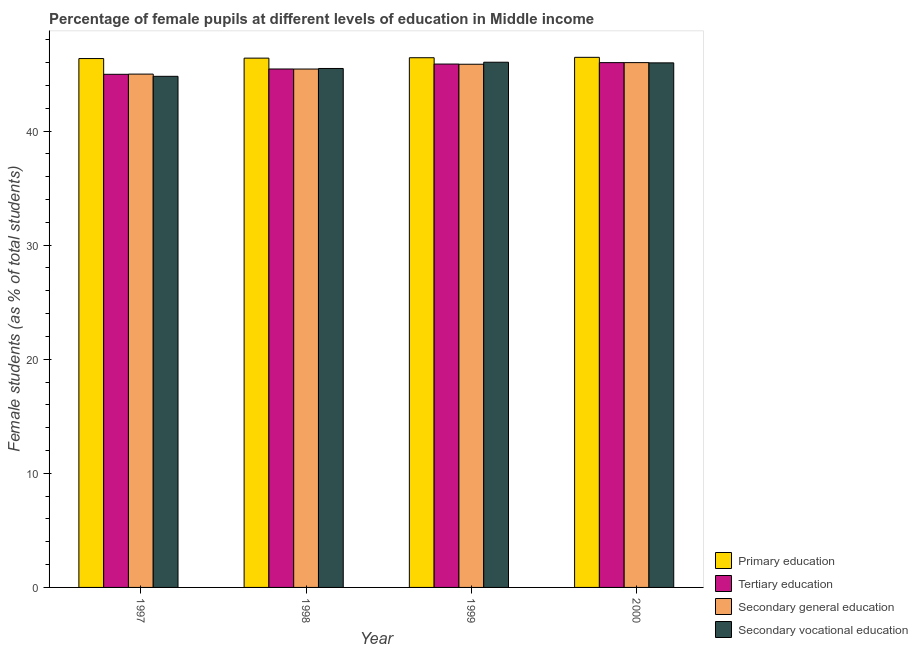Are the number of bars per tick equal to the number of legend labels?
Make the answer very short. Yes. How many bars are there on the 3rd tick from the right?
Offer a terse response. 4. What is the label of the 2nd group of bars from the left?
Give a very brief answer. 1998. In how many cases, is the number of bars for a given year not equal to the number of legend labels?
Keep it short and to the point. 0. What is the percentage of female students in secondary education in 1998?
Make the answer very short. 45.44. Across all years, what is the maximum percentage of female students in secondary education?
Provide a succinct answer. 46. Across all years, what is the minimum percentage of female students in primary education?
Offer a very short reply. 46.36. In which year was the percentage of female students in secondary vocational education maximum?
Give a very brief answer. 1999. In which year was the percentage of female students in secondary vocational education minimum?
Your response must be concise. 1997. What is the total percentage of female students in primary education in the graph?
Your answer should be compact. 185.65. What is the difference between the percentage of female students in primary education in 1998 and that in 1999?
Your answer should be compact. -0.04. What is the difference between the percentage of female students in secondary vocational education in 1998 and the percentage of female students in primary education in 2000?
Offer a terse response. -0.49. What is the average percentage of female students in secondary education per year?
Your answer should be compact. 45.57. What is the ratio of the percentage of female students in primary education in 1999 to that in 2000?
Provide a succinct answer. 1. Is the difference between the percentage of female students in secondary education in 1997 and 1998 greater than the difference between the percentage of female students in primary education in 1997 and 1998?
Make the answer very short. No. What is the difference between the highest and the second highest percentage of female students in secondary vocational education?
Offer a very short reply. 0.06. What is the difference between the highest and the lowest percentage of female students in tertiary education?
Give a very brief answer. 1.02. Is it the case that in every year, the sum of the percentage of female students in secondary vocational education and percentage of female students in secondary education is greater than the sum of percentage of female students in primary education and percentage of female students in tertiary education?
Provide a short and direct response. No. What does the 1st bar from the left in 2000 represents?
Give a very brief answer. Primary education. What does the 3rd bar from the right in 2000 represents?
Your answer should be very brief. Tertiary education. Is it the case that in every year, the sum of the percentage of female students in primary education and percentage of female students in tertiary education is greater than the percentage of female students in secondary education?
Your answer should be compact. Yes. How many bars are there?
Make the answer very short. 16. What is the difference between two consecutive major ticks on the Y-axis?
Provide a succinct answer. 10. Are the values on the major ticks of Y-axis written in scientific E-notation?
Ensure brevity in your answer.  No. Does the graph contain any zero values?
Keep it short and to the point. No. Does the graph contain grids?
Provide a short and direct response. No. How many legend labels are there?
Offer a very short reply. 4. How are the legend labels stacked?
Give a very brief answer. Vertical. What is the title of the graph?
Your response must be concise. Percentage of female pupils at different levels of education in Middle income. Does "Greece" appear as one of the legend labels in the graph?
Ensure brevity in your answer.  No. What is the label or title of the X-axis?
Your answer should be very brief. Year. What is the label or title of the Y-axis?
Offer a very short reply. Female students (as % of total students). What is the Female students (as % of total students) in Primary education in 1997?
Ensure brevity in your answer.  46.36. What is the Female students (as % of total students) in Tertiary education in 1997?
Make the answer very short. 44.98. What is the Female students (as % of total students) of Secondary general education in 1997?
Give a very brief answer. 44.99. What is the Female students (as % of total students) of Secondary vocational education in 1997?
Provide a succinct answer. 44.8. What is the Female students (as % of total students) of Primary education in 1998?
Provide a short and direct response. 46.39. What is the Female students (as % of total students) in Tertiary education in 1998?
Provide a short and direct response. 45.44. What is the Female students (as % of total students) of Secondary general education in 1998?
Offer a very short reply. 45.44. What is the Female students (as % of total students) of Secondary vocational education in 1998?
Your answer should be very brief. 45.49. What is the Female students (as % of total students) in Primary education in 1999?
Ensure brevity in your answer.  46.43. What is the Female students (as % of total students) of Tertiary education in 1999?
Provide a succinct answer. 45.88. What is the Female students (as % of total students) in Secondary general education in 1999?
Your response must be concise. 45.86. What is the Female students (as % of total students) in Secondary vocational education in 1999?
Make the answer very short. 46.04. What is the Female students (as % of total students) in Primary education in 2000?
Your answer should be compact. 46.46. What is the Female students (as % of total students) in Tertiary education in 2000?
Keep it short and to the point. 46. What is the Female students (as % of total students) of Secondary general education in 2000?
Give a very brief answer. 46. What is the Female students (as % of total students) of Secondary vocational education in 2000?
Offer a terse response. 45.98. Across all years, what is the maximum Female students (as % of total students) in Primary education?
Keep it short and to the point. 46.46. Across all years, what is the maximum Female students (as % of total students) in Tertiary education?
Make the answer very short. 46. Across all years, what is the maximum Female students (as % of total students) of Secondary general education?
Provide a short and direct response. 46. Across all years, what is the maximum Female students (as % of total students) of Secondary vocational education?
Make the answer very short. 46.04. Across all years, what is the minimum Female students (as % of total students) of Primary education?
Ensure brevity in your answer.  46.36. Across all years, what is the minimum Female students (as % of total students) in Tertiary education?
Give a very brief answer. 44.98. Across all years, what is the minimum Female students (as % of total students) of Secondary general education?
Make the answer very short. 44.99. Across all years, what is the minimum Female students (as % of total students) in Secondary vocational education?
Provide a short and direct response. 44.8. What is the total Female students (as % of total students) of Primary education in the graph?
Your answer should be compact. 185.65. What is the total Female students (as % of total students) in Tertiary education in the graph?
Ensure brevity in your answer.  182.29. What is the total Female students (as % of total students) of Secondary general education in the graph?
Provide a succinct answer. 182.29. What is the total Female students (as % of total students) in Secondary vocational education in the graph?
Your answer should be very brief. 182.3. What is the difference between the Female students (as % of total students) in Primary education in 1997 and that in 1998?
Your answer should be compact. -0.04. What is the difference between the Female students (as % of total students) in Tertiary education in 1997 and that in 1998?
Your answer should be very brief. -0.47. What is the difference between the Female students (as % of total students) in Secondary general education in 1997 and that in 1998?
Give a very brief answer. -0.44. What is the difference between the Female students (as % of total students) of Secondary vocational education in 1997 and that in 1998?
Provide a short and direct response. -0.69. What is the difference between the Female students (as % of total students) of Primary education in 1997 and that in 1999?
Keep it short and to the point. -0.07. What is the difference between the Female students (as % of total students) in Tertiary education in 1997 and that in 1999?
Make the answer very short. -0.9. What is the difference between the Female students (as % of total students) in Secondary general education in 1997 and that in 1999?
Give a very brief answer. -0.87. What is the difference between the Female students (as % of total students) of Secondary vocational education in 1997 and that in 1999?
Make the answer very short. -1.24. What is the difference between the Female students (as % of total students) of Primary education in 1997 and that in 2000?
Ensure brevity in your answer.  -0.11. What is the difference between the Female students (as % of total students) of Tertiary education in 1997 and that in 2000?
Provide a succinct answer. -1.02. What is the difference between the Female students (as % of total students) of Secondary general education in 1997 and that in 2000?
Offer a terse response. -1.01. What is the difference between the Female students (as % of total students) of Secondary vocational education in 1997 and that in 2000?
Give a very brief answer. -1.18. What is the difference between the Female students (as % of total students) in Primary education in 1998 and that in 1999?
Provide a short and direct response. -0.04. What is the difference between the Female students (as % of total students) of Tertiary education in 1998 and that in 1999?
Your response must be concise. -0.43. What is the difference between the Female students (as % of total students) of Secondary general education in 1998 and that in 1999?
Keep it short and to the point. -0.42. What is the difference between the Female students (as % of total students) of Secondary vocational education in 1998 and that in 1999?
Your answer should be very brief. -0.55. What is the difference between the Female students (as % of total students) in Primary education in 1998 and that in 2000?
Your answer should be very brief. -0.07. What is the difference between the Female students (as % of total students) in Tertiary education in 1998 and that in 2000?
Give a very brief answer. -0.56. What is the difference between the Female students (as % of total students) of Secondary general education in 1998 and that in 2000?
Give a very brief answer. -0.56. What is the difference between the Female students (as % of total students) of Secondary vocational education in 1998 and that in 2000?
Provide a short and direct response. -0.49. What is the difference between the Female students (as % of total students) of Primary education in 1999 and that in 2000?
Offer a terse response. -0.03. What is the difference between the Female students (as % of total students) in Tertiary education in 1999 and that in 2000?
Your response must be concise. -0.12. What is the difference between the Female students (as % of total students) in Secondary general education in 1999 and that in 2000?
Ensure brevity in your answer.  -0.14. What is the difference between the Female students (as % of total students) in Secondary vocational education in 1999 and that in 2000?
Provide a succinct answer. 0.06. What is the difference between the Female students (as % of total students) in Primary education in 1997 and the Female students (as % of total students) in Tertiary education in 1998?
Your response must be concise. 0.91. What is the difference between the Female students (as % of total students) of Primary education in 1997 and the Female students (as % of total students) of Secondary general education in 1998?
Your response must be concise. 0.92. What is the difference between the Female students (as % of total students) in Primary education in 1997 and the Female students (as % of total students) in Secondary vocational education in 1998?
Your answer should be very brief. 0.87. What is the difference between the Female students (as % of total students) in Tertiary education in 1997 and the Female students (as % of total students) in Secondary general education in 1998?
Offer a very short reply. -0.46. What is the difference between the Female students (as % of total students) in Tertiary education in 1997 and the Female students (as % of total students) in Secondary vocational education in 1998?
Ensure brevity in your answer.  -0.51. What is the difference between the Female students (as % of total students) in Secondary general education in 1997 and the Female students (as % of total students) in Secondary vocational education in 1998?
Give a very brief answer. -0.49. What is the difference between the Female students (as % of total students) of Primary education in 1997 and the Female students (as % of total students) of Tertiary education in 1999?
Your response must be concise. 0.48. What is the difference between the Female students (as % of total students) in Primary education in 1997 and the Female students (as % of total students) in Secondary general education in 1999?
Give a very brief answer. 0.5. What is the difference between the Female students (as % of total students) in Primary education in 1997 and the Female students (as % of total students) in Secondary vocational education in 1999?
Your answer should be compact. 0.32. What is the difference between the Female students (as % of total students) in Tertiary education in 1997 and the Female students (as % of total students) in Secondary general education in 1999?
Your answer should be compact. -0.88. What is the difference between the Female students (as % of total students) in Tertiary education in 1997 and the Female students (as % of total students) in Secondary vocational education in 1999?
Give a very brief answer. -1.06. What is the difference between the Female students (as % of total students) of Secondary general education in 1997 and the Female students (as % of total students) of Secondary vocational education in 1999?
Keep it short and to the point. -1.04. What is the difference between the Female students (as % of total students) in Primary education in 1997 and the Female students (as % of total students) in Tertiary education in 2000?
Provide a succinct answer. 0.36. What is the difference between the Female students (as % of total students) in Primary education in 1997 and the Female students (as % of total students) in Secondary general education in 2000?
Offer a terse response. 0.36. What is the difference between the Female students (as % of total students) of Primary education in 1997 and the Female students (as % of total students) of Secondary vocational education in 2000?
Your response must be concise. 0.38. What is the difference between the Female students (as % of total students) in Tertiary education in 1997 and the Female students (as % of total students) in Secondary general education in 2000?
Offer a terse response. -1.03. What is the difference between the Female students (as % of total students) in Tertiary education in 1997 and the Female students (as % of total students) in Secondary vocational education in 2000?
Offer a terse response. -1. What is the difference between the Female students (as % of total students) in Secondary general education in 1997 and the Female students (as % of total students) in Secondary vocational education in 2000?
Provide a short and direct response. -0.99. What is the difference between the Female students (as % of total students) in Primary education in 1998 and the Female students (as % of total students) in Tertiary education in 1999?
Give a very brief answer. 0.52. What is the difference between the Female students (as % of total students) of Primary education in 1998 and the Female students (as % of total students) of Secondary general education in 1999?
Ensure brevity in your answer.  0.54. What is the difference between the Female students (as % of total students) of Primary education in 1998 and the Female students (as % of total students) of Secondary vocational education in 1999?
Your response must be concise. 0.36. What is the difference between the Female students (as % of total students) of Tertiary education in 1998 and the Female students (as % of total students) of Secondary general education in 1999?
Your answer should be very brief. -0.42. What is the difference between the Female students (as % of total students) of Tertiary education in 1998 and the Female students (as % of total students) of Secondary vocational education in 1999?
Make the answer very short. -0.59. What is the difference between the Female students (as % of total students) of Secondary general education in 1998 and the Female students (as % of total students) of Secondary vocational education in 1999?
Your answer should be compact. -0.6. What is the difference between the Female students (as % of total students) of Primary education in 1998 and the Female students (as % of total students) of Tertiary education in 2000?
Your answer should be compact. 0.4. What is the difference between the Female students (as % of total students) of Primary education in 1998 and the Female students (as % of total students) of Secondary general education in 2000?
Your response must be concise. 0.39. What is the difference between the Female students (as % of total students) in Primary education in 1998 and the Female students (as % of total students) in Secondary vocational education in 2000?
Offer a terse response. 0.42. What is the difference between the Female students (as % of total students) of Tertiary education in 1998 and the Female students (as % of total students) of Secondary general education in 2000?
Your answer should be compact. -0.56. What is the difference between the Female students (as % of total students) in Tertiary education in 1998 and the Female students (as % of total students) in Secondary vocational education in 2000?
Give a very brief answer. -0.54. What is the difference between the Female students (as % of total students) of Secondary general education in 1998 and the Female students (as % of total students) of Secondary vocational education in 2000?
Offer a very short reply. -0.54. What is the difference between the Female students (as % of total students) in Primary education in 1999 and the Female students (as % of total students) in Tertiary education in 2000?
Offer a very short reply. 0.43. What is the difference between the Female students (as % of total students) in Primary education in 1999 and the Female students (as % of total students) in Secondary general education in 2000?
Keep it short and to the point. 0.43. What is the difference between the Female students (as % of total students) in Primary education in 1999 and the Female students (as % of total students) in Secondary vocational education in 2000?
Your answer should be very brief. 0.45. What is the difference between the Female students (as % of total students) of Tertiary education in 1999 and the Female students (as % of total students) of Secondary general education in 2000?
Keep it short and to the point. -0.13. What is the difference between the Female students (as % of total students) of Tertiary education in 1999 and the Female students (as % of total students) of Secondary vocational education in 2000?
Provide a succinct answer. -0.1. What is the difference between the Female students (as % of total students) in Secondary general education in 1999 and the Female students (as % of total students) in Secondary vocational education in 2000?
Your response must be concise. -0.12. What is the average Female students (as % of total students) in Primary education per year?
Your response must be concise. 46.41. What is the average Female students (as % of total students) of Tertiary education per year?
Make the answer very short. 45.57. What is the average Female students (as % of total students) of Secondary general education per year?
Make the answer very short. 45.57. What is the average Female students (as % of total students) of Secondary vocational education per year?
Make the answer very short. 45.58. In the year 1997, what is the difference between the Female students (as % of total students) of Primary education and Female students (as % of total students) of Tertiary education?
Your answer should be compact. 1.38. In the year 1997, what is the difference between the Female students (as % of total students) in Primary education and Female students (as % of total students) in Secondary general education?
Give a very brief answer. 1.36. In the year 1997, what is the difference between the Female students (as % of total students) of Primary education and Female students (as % of total students) of Secondary vocational education?
Provide a succinct answer. 1.56. In the year 1997, what is the difference between the Female students (as % of total students) in Tertiary education and Female students (as % of total students) in Secondary general education?
Ensure brevity in your answer.  -0.02. In the year 1997, what is the difference between the Female students (as % of total students) of Tertiary education and Female students (as % of total students) of Secondary vocational education?
Provide a short and direct response. 0.18. In the year 1997, what is the difference between the Female students (as % of total students) in Secondary general education and Female students (as % of total students) in Secondary vocational education?
Provide a short and direct response. 0.19. In the year 1998, what is the difference between the Female students (as % of total students) of Primary education and Female students (as % of total students) of Tertiary education?
Your answer should be compact. 0.95. In the year 1998, what is the difference between the Female students (as % of total students) in Primary education and Female students (as % of total students) in Secondary general education?
Give a very brief answer. 0.96. In the year 1998, what is the difference between the Female students (as % of total students) in Primary education and Female students (as % of total students) in Secondary vocational education?
Offer a very short reply. 0.91. In the year 1998, what is the difference between the Female students (as % of total students) in Tertiary education and Female students (as % of total students) in Secondary general education?
Your answer should be very brief. 0. In the year 1998, what is the difference between the Female students (as % of total students) of Tertiary education and Female students (as % of total students) of Secondary vocational education?
Your response must be concise. -0.04. In the year 1998, what is the difference between the Female students (as % of total students) in Secondary general education and Female students (as % of total students) in Secondary vocational education?
Make the answer very short. -0.05. In the year 1999, what is the difference between the Female students (as % of total students) in Primary education and Female students (as % of total students) in Tertiary education?
Offer a very short reply. 0.56. In the year 1999, what is the difference between the Female students (as % of total students) of Primary education and Female students (as % of total students) of Secondary general education?
Keep it short and to the point. 0.57. In the year 1999, what is the difference between the Female students (as % of total students) of Primary education and Female students (as % of total students) of Secondary vocational education?
Make the answer very short. 0.39. In the year 1999, what is the difference between the Female students (as % of total students) of Tertiary education and Female students (as % of total students) of Secondary general education?
Make the answer very short. 0.02. In the year 1999, what is the difference between the Female students (as % of total students) in Tertiary education and Female students (as % of total students) in Secondary vocational education?
Make the answer very short. -0.16. In the year 1999, what is the difference between the Female students (as % of total students) of Secondary general education and Female students (as % of total students) of Secondary vocational education?
Provide a short and direct response. -0.18. In the year 2000, what is the difference between the Female students (as % of total students) of Primary education and Female students (as % of total students) of Tertiary education?
Ensure brevity in your answer.  0.47. In the year 2000, what is the difference between the Female students (as % of total students) of Primary education and Female students (as % of total students) of Secondary general education?
Give a very brief answer. 0.46. In the year 2000, what is the difference between the Female students (as % of total students) in Primary education and Female students (as % of total students) in Secondary vocational education?
Keep it short and to the point. 0.49. In the year 2000, what is the difference between the Female students (as % of total students) of Tertiary education and Female students (as % of total students) of Secondary general education?
Your response must be concise. -0. In the year 2000, what is the difference between the Female students (as % of total students) of Tertiary education and Female students (as % of total students) of Secondary vocational education?
Provide a succinct answer. 0.02. In the year 2000, what is the difference between the Female students (as % of total students) in Secondary general education and Female students (as % of total students) in Secondary vocational education?
Ensure brevity in your answer.  0.02. What is the ratio of the Female students (as % of total students) in Primary education in 1997 to that in 1998?
Your answer should be very brief. 1. What is the ratio of the Female students (as % of total students) of Tertiary education in 1997 to that in 1998?
Keep it short and to the point. 0.99. What is the ratio of the Female students (as % of total students) of Secondary general education in 1997 to that in 1998?
Your response must be concise. 0.99. What is the ratio of the Female students (as % of total students) of Secondary vocational education in 1997 to that in 1998?
Your answer should be very brief. 0.98. What is the ratio of the Female students (as % of total students) in Primary education in 1997 to that in 1999?
Your answer should be very brief. 1. What is the ratio of the Female students (as % of total students) in Tertiary education in 1997 to that in 1999?
Give a very brief answer. 0.98. What is the ratio of the Female students (as % of total students) in Secondary general education in 1997 to that in 1999?
Provide a succinct answer. 0.98. What is the ratio of the Female students (as % of total students) of Secondary vocational education in 1997 to that in 1999?
Your answer should be very brief. 0.97. What is the ratio of the Female students (as % of total students) of Primary education in 1997 to that in 2000?
Keep it short and to the point. 1. What is the ratio of the Female students (as % of total students) in Tertiary education in 1997 to that in 2000?
Provide a short and direct response. 0.98. What is the ratio of the Female students (as % of total students) of Secondary general education in 1997 to that in 2000?
Provide a short and direct response. 0.98. What is the ratio of the Female students (as % of total students) of Secondary vocational education in 1997 to that in 2000?
Your response must be concise. 0.97. What is the ratio of the Female students (as % of total students) in Tertiary education in 1998 to that in 1999?
Your answer should be compact. 0.99. What is the ratio of the Female students (as % of total students) of Secondary general education in 1998 to that in 1999?
Make the answer very short. 0.99. What is the ratio of the Female students (as % of total students) of Tertiary education in 1998 to that in 2000?
Keep it short and to the point. 0.99. What is the ratio of the Female students (as % of total students) of Secondary general education in 1998 to that in 2000?
Your answer should be compact. 0.99. What is the ratio of the Female students (as % of total students) of Secondary vocational education in 1998 to that in 2000?
Your answer should be compact. 0.99. What is the ratio of the Female students (as % of total students) of Primary education in 1999 to that in 2000?
Your response must be concise. 1. What is the ratio of the Female students (as % of total students) in Secondary vocational education in 1999 to that in 2000?
Offer a terse response. 1. What is the difference between the highest and the second highest Female students (as % of total students) in Primary education?
Your response must be concise. 0.03. What is the difference between the highest and the second highest Female students (as % of total students) of Tertiary education?
Offer a terse response. 0.12. What is the difference between the highest and the second highest Female students (as % of total students) in Secondary general education?
Provide a succinct answer. 0.14. What is the difference between the highest and the second highest Female students (as % of total students) in Secondary vocational education?
Offer a terse response. 0.06. What is the difference between the highest and the lowest Female students (as % of total students) of Primary education?
Offer a terse response. 0.11. What is the difference between the highest and the lowest Female students (as % of total students) in Tertiary education?
Provide a short and direct response. 1.02. What is the difference between the highest and the lowest Female students (as % of total students) in Secondary general education?
Offer a terse response. 1.01. What is the difference between the highest and the lowest Female students (as % of total students) of Secondary vocational education?
Make the answer very short. 1.24. 